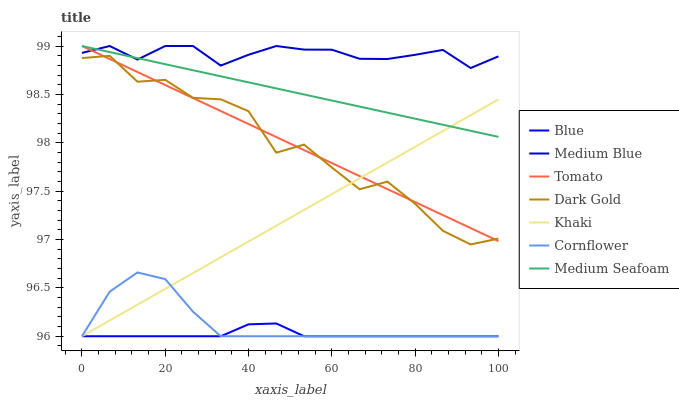Does Blue have the minimum area under the curve?
Answer yes or no. Yes. Does Medium Blue have the maximum area under the curve?
Answer yes or no. Yes. Does Tomato have the minimum area under the curve?
Answer yes or no. No. Does Tomato have the maximum area under the curve?
Answer yes or no. No. Is Tomato the smoothest?
Answer yes or no. Yes. Is Dark Gold the roughest?
Answer yes or no. Yes. Is Khaki the smoothest?
Answer yes or no. No. Is Khaki the roughest?
Answer yes or no. No. Does Blue have the lowest value?
Answer yes or no. Yes. Does Tomato have the lowest value?
Answer yes or no. No. Does Medium Seafoam have the highest value?
Answer yes or no. Yes. Does Khaki have the highest value?
Answer yes or no. No. Is Dark Gold less than Medium Blue?
Answer yes or no. Yes. Is Dark Gold greater than Cornflower?
Answer yes or no. Yes. Does Blue intersect Khaki?
Answer yes or no. Yes. Is Blue less than Khaki?
Answer yes or no. No. Is Blue greater than Khaki?
Answer yes or no. No. Does Dark Gold intersect Medium Blue?
Answer yes or no. No. 